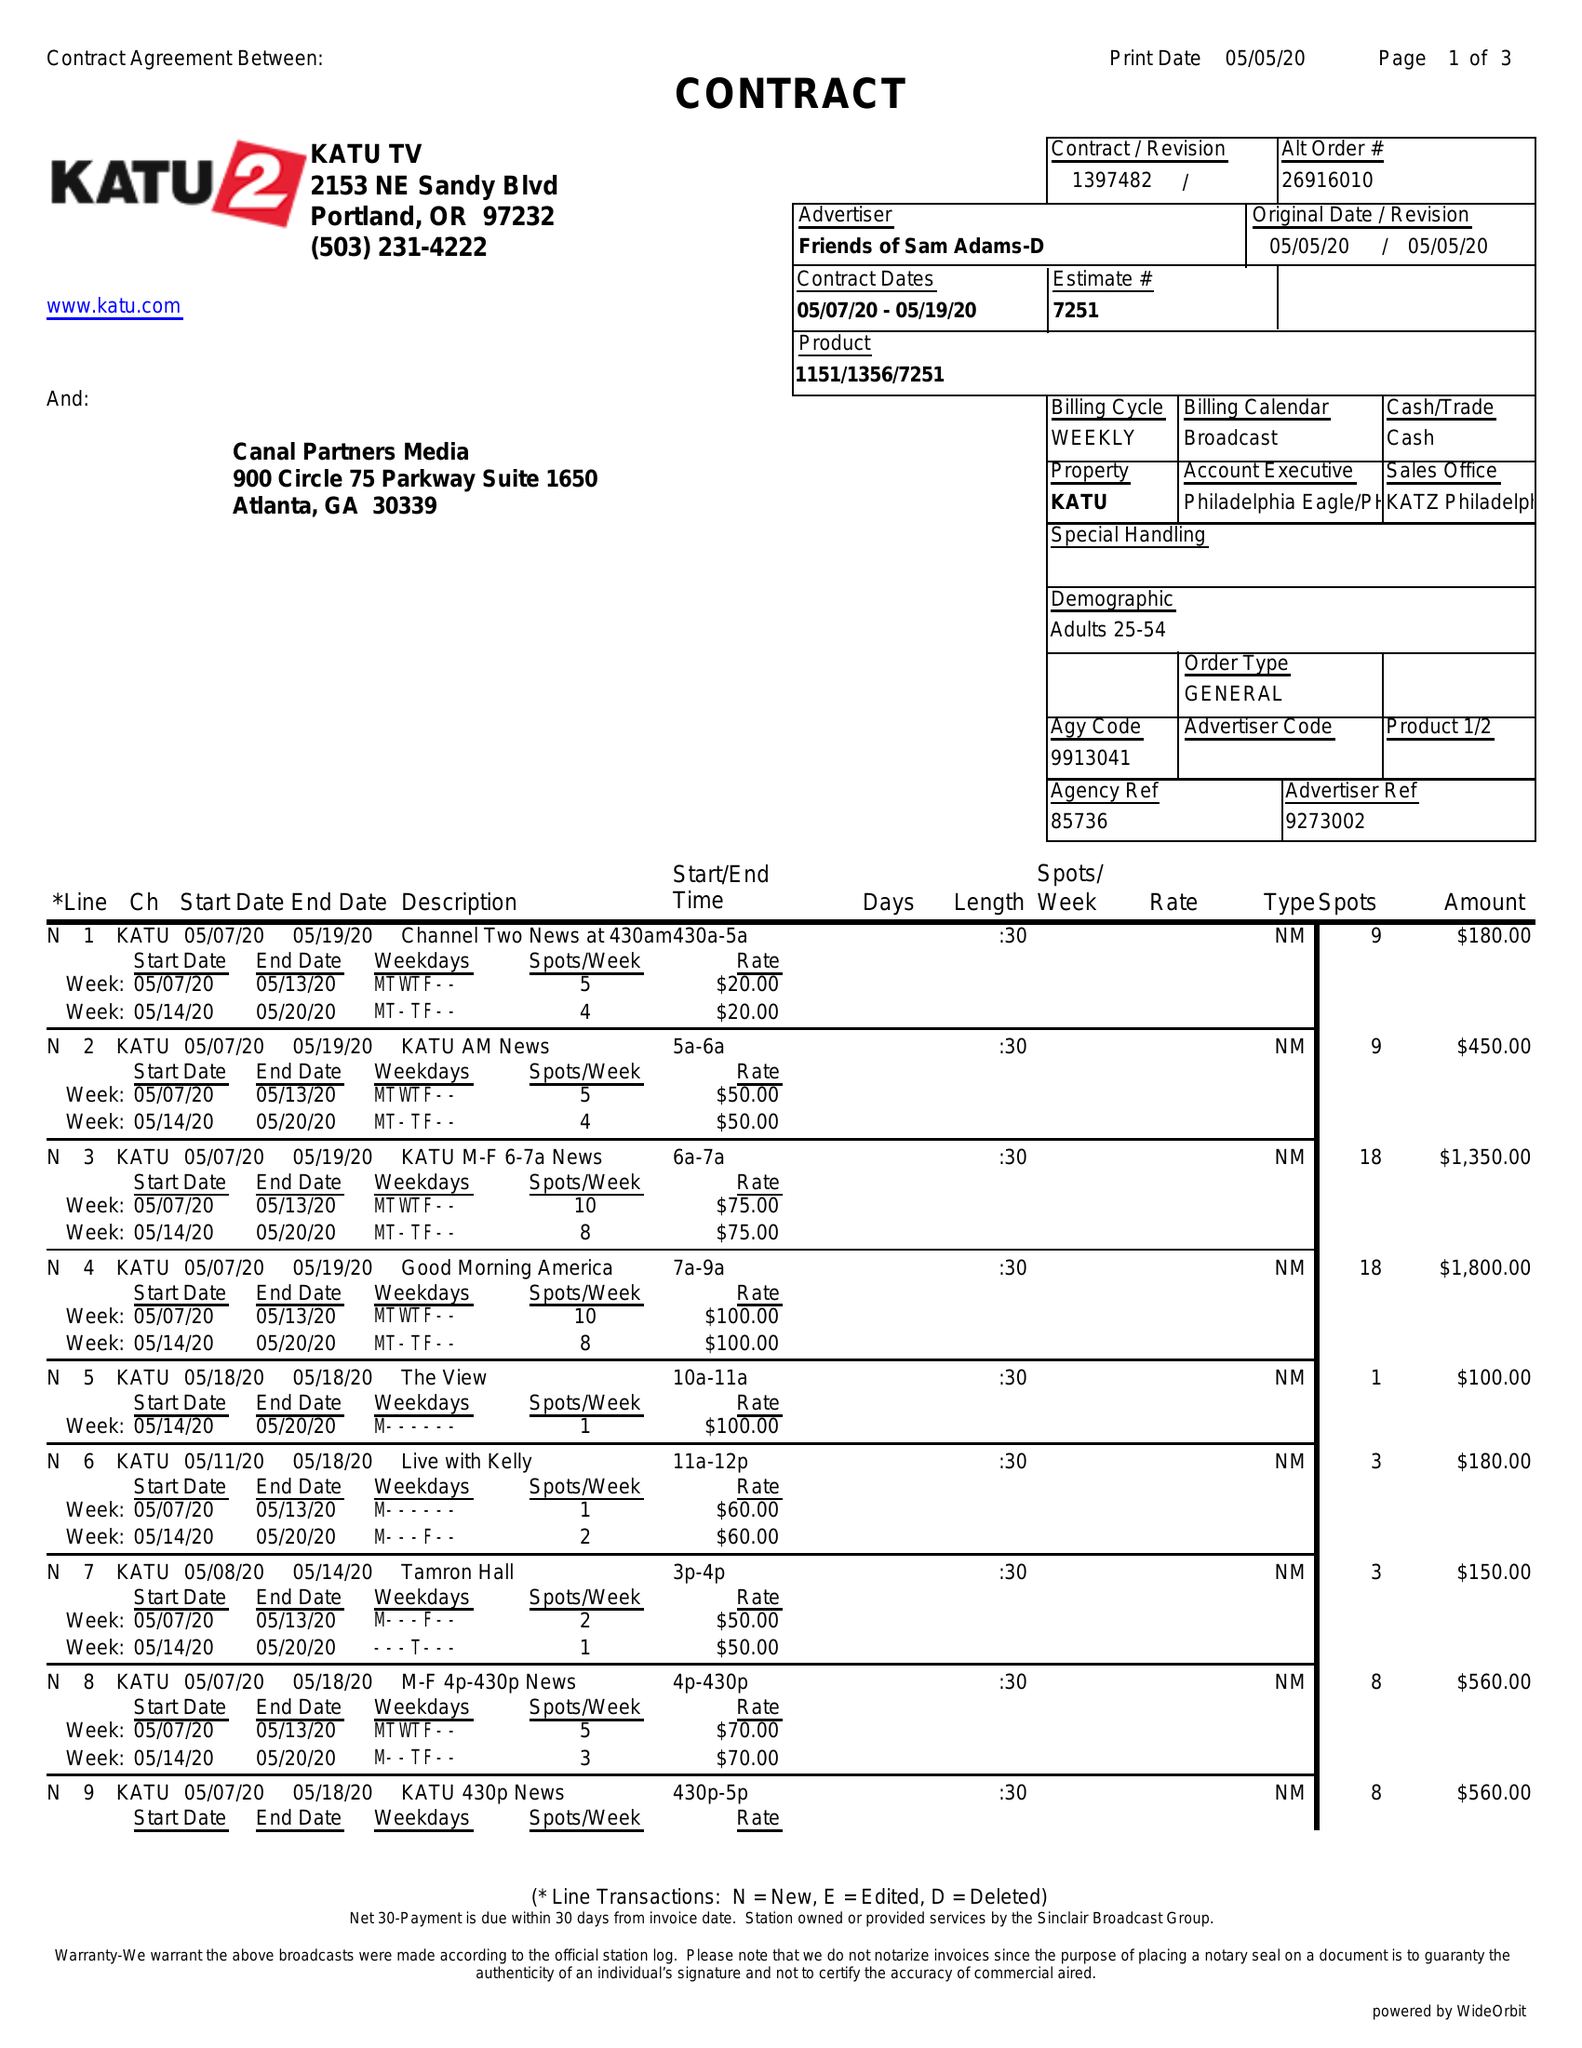What is the value for the gross_amount?
Answer the question using a single word or phrase. 19755.00 